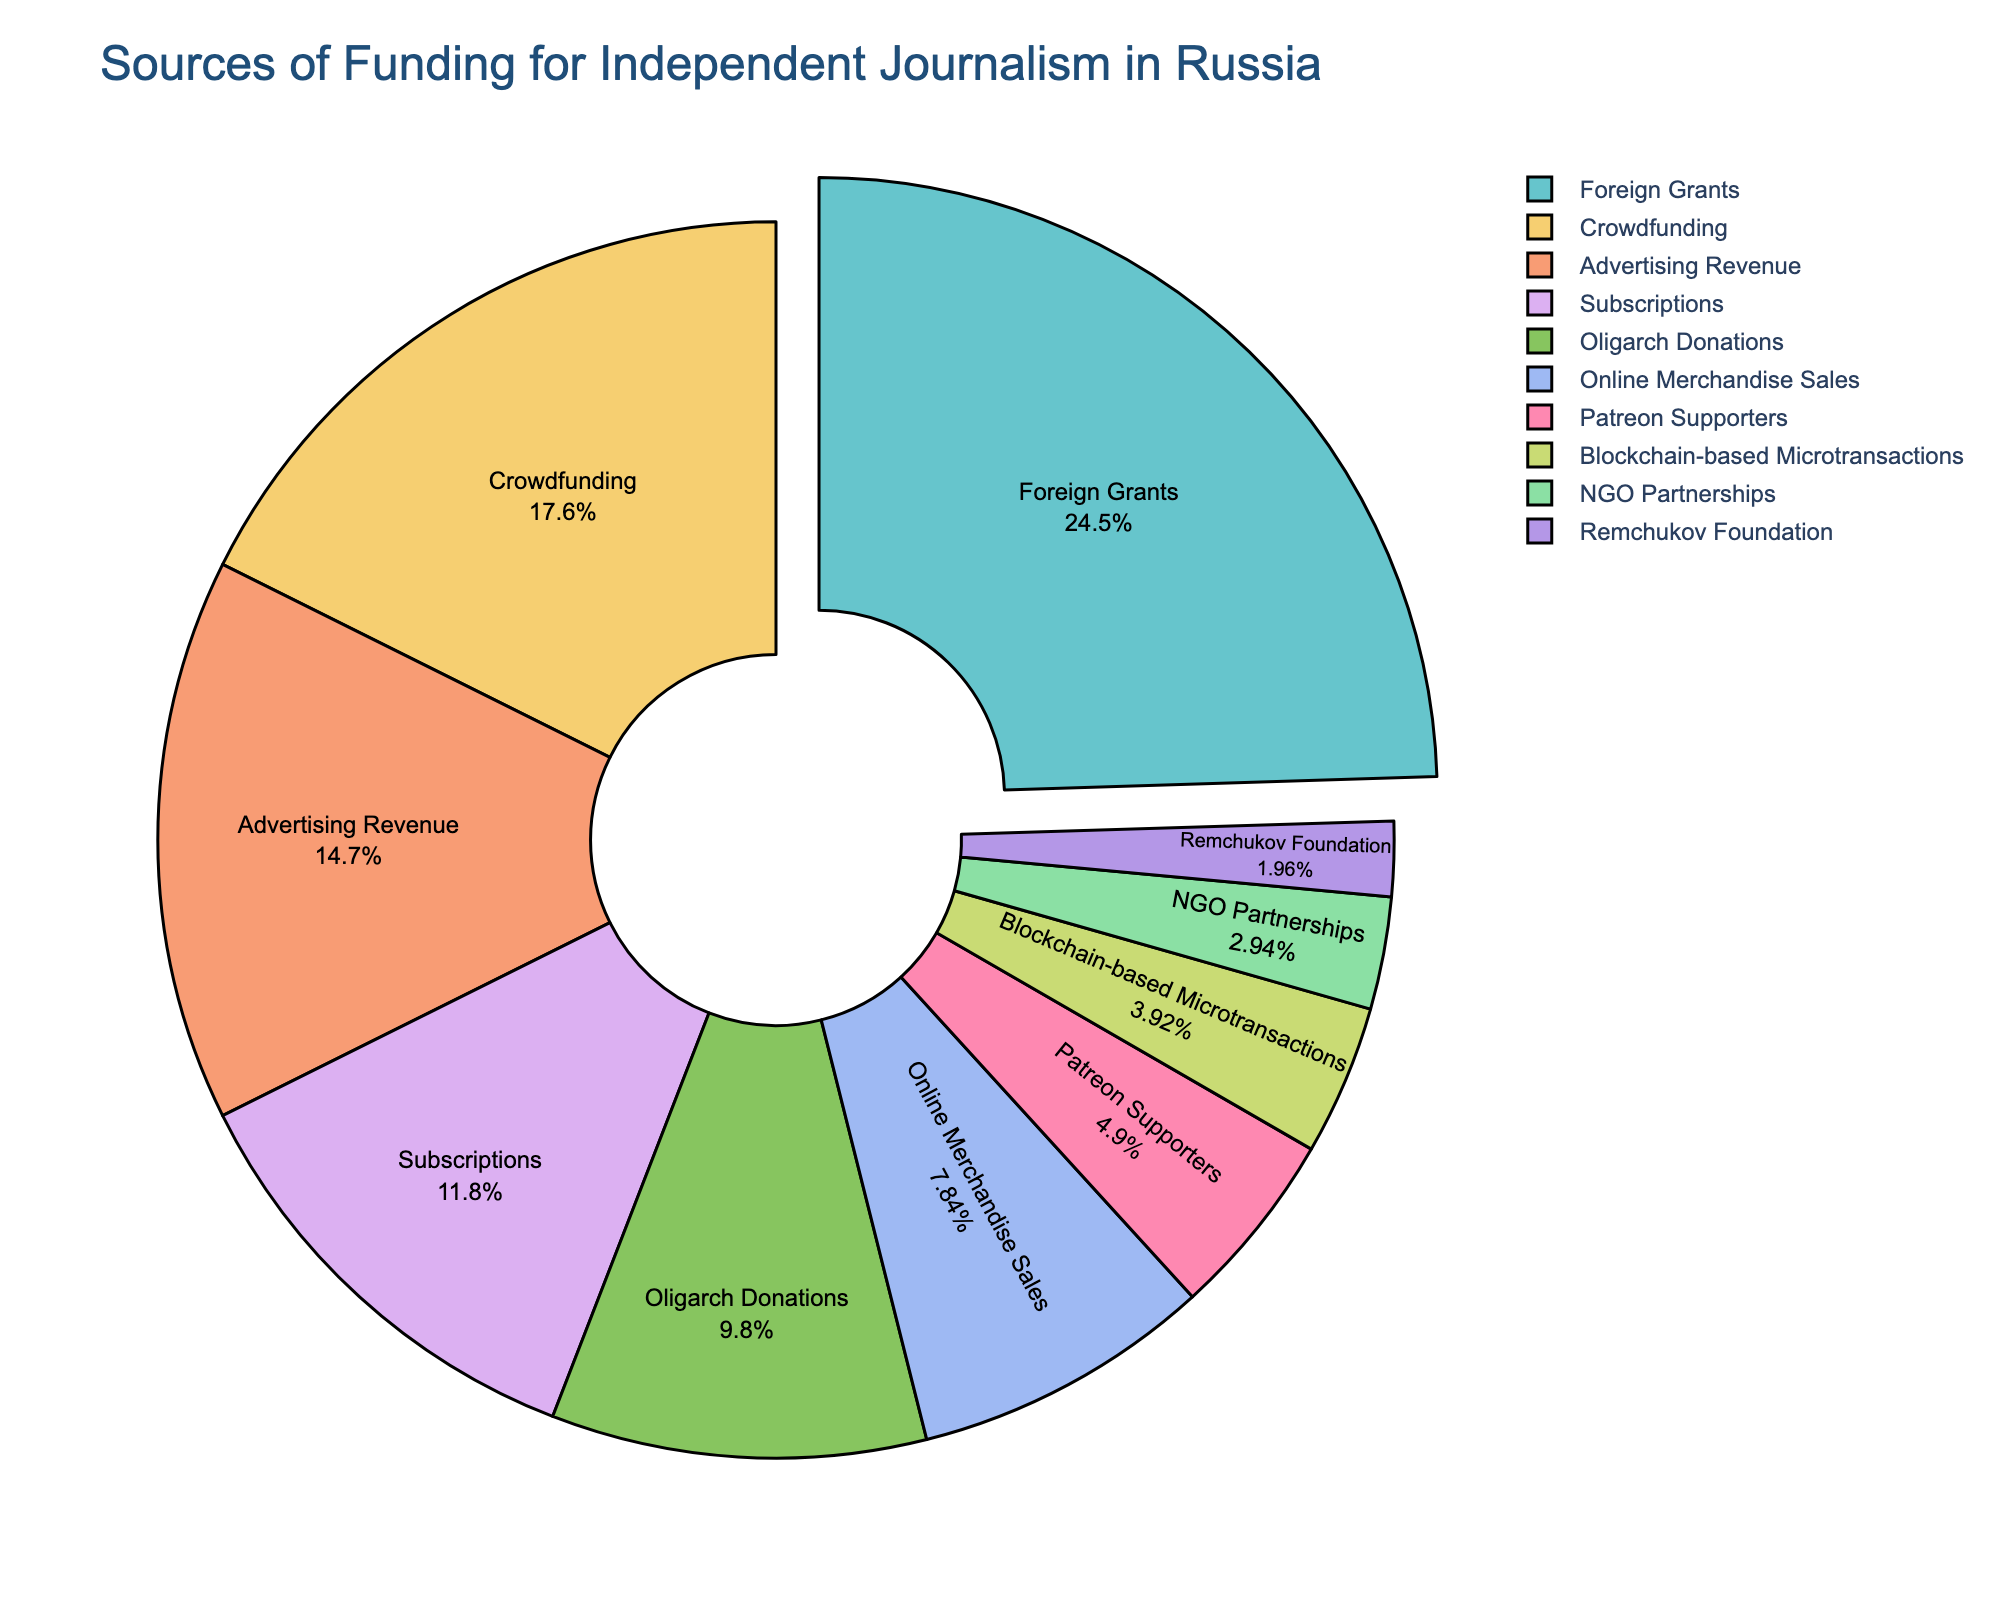What's the most significant source of funding for independent journalism in Russia? To determine the most significant source of funding, look at the entity with the largest percentage in the pie chart.
Answer: Foreign Grants How much more funding do Foreign Grants provide compared to Advertising Revenue? First, note the percentages for Foreign Grants (25%) and Advertising Revenue (15%). Then, find the difference: 25% - 15% = 10%.
Answer: 10% What is the combined percentage of funding from Crowdfunding and Subscriptions? Note the percentages for Crowdfunding (18%) and Subscriptions (12%). Add them: 18% + 12% = 30%.
Answer: 30% Which funding source forms the smallest percentage of the total funding? Identify the entity with the smallest percentage in the pie chart, which is Remchukov Foundation with 2%.
Answer: Remchukov Foundation Does Crowdfunding provide more funding than Advertising Revenue and Subscriptions combined? Note the percentages for Crowdfunding (18%), Advertising Revenue (15%), and Subscriptions (12%). Add Advertising Revenue and Subscriptions: 15% + 12% = 27%. Since 18% < 27%, Crowdfunding provides less funding.
Answer: No How many sources provide less than 10% of total funding individually? Identify the entities with percentages less than 10%: Online Merchandise Sales (8%), Patreon Supporters (5%), Blockchain-based Microtransactions (4%), NGO Partnerships (3%), and Remchukov Foundation (2%). Count them: 5 sources.
Answer: 5 What's the difference in funding percentages between the third and fourth largest sources? Note the percentages for the third largest source, Advertising Revenue (15%), and the fourth largest source, Subscriptions (12%). Find the difference: 15% - 12% = 3%.
Answer: 3% What proportion of the funding comes from traditional revenue streams like Advertising Revenue and Subscriptions compared to newer forms like Patreon Supporters and Blockchain-based Microtransactions? Note the percentages: Advertising Revenue (15%), Subscriptions (12%), Patreon Supporters (5%), Blockchain-based Microtransactions (4%). Sum the traditional and newer forms: (15% + 12%) vs. (5% + 4%), which is 27% vs. 9%.
Answer: Traditional: 27%, Newer: 9% Which funding source is visually highlighted in the pie chart? Look for the segment that stands out, such as being "pulled out" or emphasized in some way. This is the segment for Foreign Grants.
Answer: Foreign Grants 